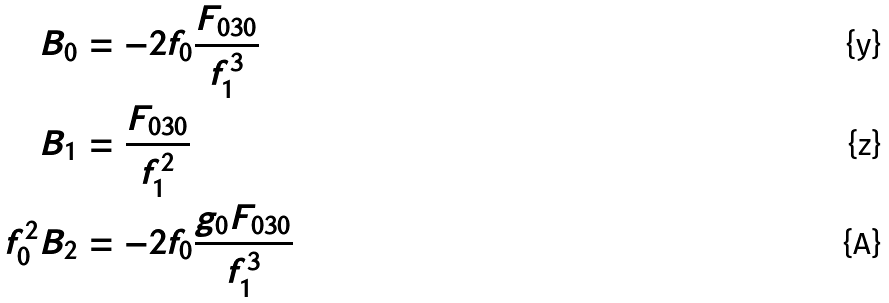<formula> <loc_0><loc_0><loc_500><loc_500>B _ { 0 } & = - 2 f _ { 0 } \frac { F _ { 0 3 0 } } { f _ { 1 } ^ { 3 } } \\ B _ { 1 } & = \frac { F _ { 0 3 0 } } { f _ { 1 } ^ { 2 } } \\ f _ { 0 } ^ { 2 } B _ { 2 } & = - 2 f _ { 0 } \frac { g _ { 0 } F _ { 0 3 0 } } { f _ { 1 } ^ { 3 } }</formula> 